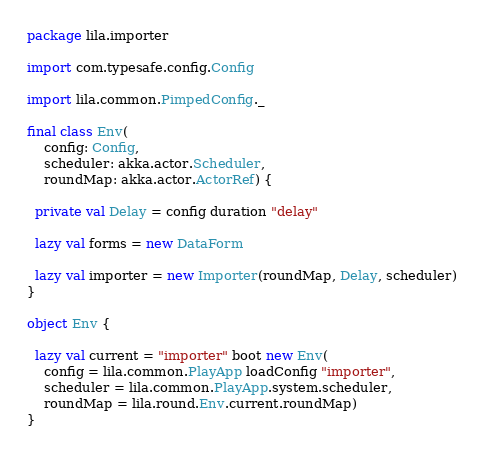<code> <loc_0><loc_0><loc_500><loc_500><_Scala_>package lila.importer

import com.typesafe.config.Config

import lila.common.PimpedConfig._

final class Env(
    config: Config,
    scheduler: akka.actor.Scheduler,
    roundMap: akka.actor.ActorRef) {

  private val Delay = config duration "delay"

  lazy val forms = new DataForm

  lazy val importer = new Importer(roundMap, Delay, scheduler)
}

object Env {

  lazy val current = "importer" boot new Env(
    config = lila.common.PlayApp loadConfig "importer",
    scheduler = lila.common.PlayApp.system.scheduler,
    roundMap = lila.round.Env.current.roundMap)
}
</code> 